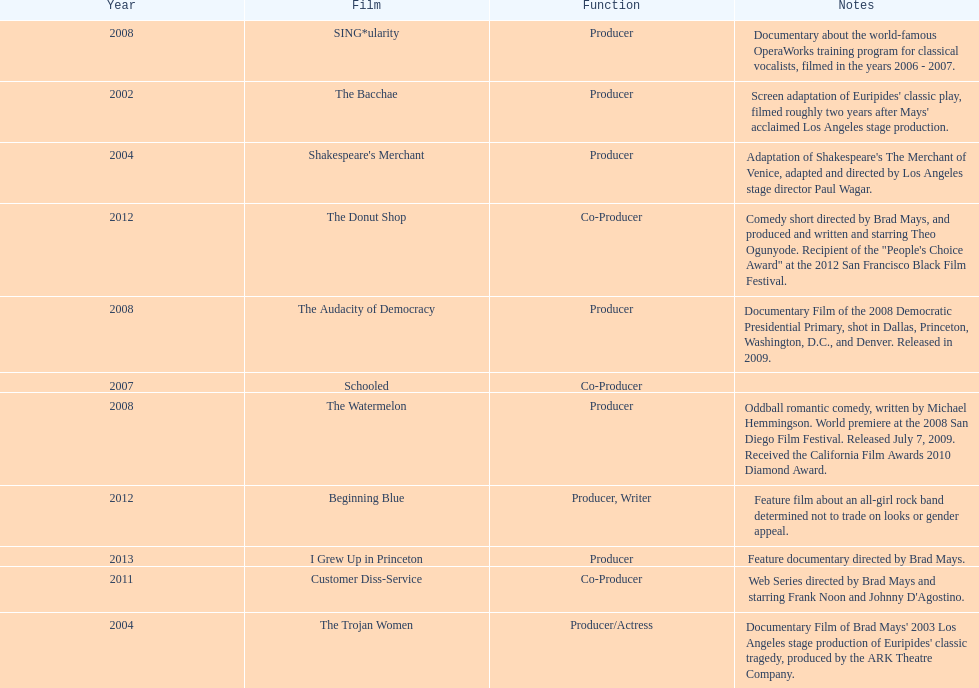In which year did ms. starfelt produce the most films? 2008. Would you mind parsing the complete table? {'header': ['Year', 'Film', 'Function', 'Notes'], 'rows': [['2008', 'SING*ularity', 'Producer', 'Documentary about the world-famous OperaWorks training program for classical vocalists, filmed in the years 2006 - 2007.'], ['2002', 'The Bacchae', 'Producer', "Screen adaptation of Euripides' classic play, filmed roughly two years after Mays' acclaimed Los Angeles stage production."], ['2004', "Shakespeare's Merchant", 'Producer', "Adaptation of Shakespeare's The Merchant of Venice, adapted and directed by Los Angeles stage director Paul Wagar."], ['2012', 'The Donut Shop', 'Co-Producer', 'Comedy short directed by Brad Mays, and produced and written and starring Theo Ogunyode. Recipient of the "People\'s Choice Award" at the 2012 San Francisco Black Film Festival.'], ['2008', 'The Audacity of Democracy', 'Producer', 'Documentary Film of the 2008 Democratic Presidential Primary, shot in Dallas, Princeton, Washington, D.C., and Denver. Released in 2009.'], ['2007', 'Schooled', 'Co-Producer', ''], ['2008', 'The Watermelon', 'Producer', 'Oddball romantic comedy, written by Michael Hemmingson. World premiere at the 2008 San Diego Film Festival. Released July 7, 2009. Received the California Film Awards 2010 Diamond Award.'], ['2012', 'Beginning Blue', 'Producer, Writer', 'Feature film about an all-girl rock band determined not to trade on looks or gender appeal.'], ['2013', 'I Grew Up in Princeton', 'Producer', 'Feature documentary directed by Brad Mays.'], ['2011', 'Customer Diss-Service', 'Co-Producer', "Web Series directed by Brad Mays and starring Frank Noon and Johnny D'Agostino."], ['2004', 'The Trojan Women', 'Producer/Actress', "Documentary Film of Brad Mays' 2003 Los Angeles stage production of Euripides' classic tragedy, produced by the ARK Theatre Company."]]} 